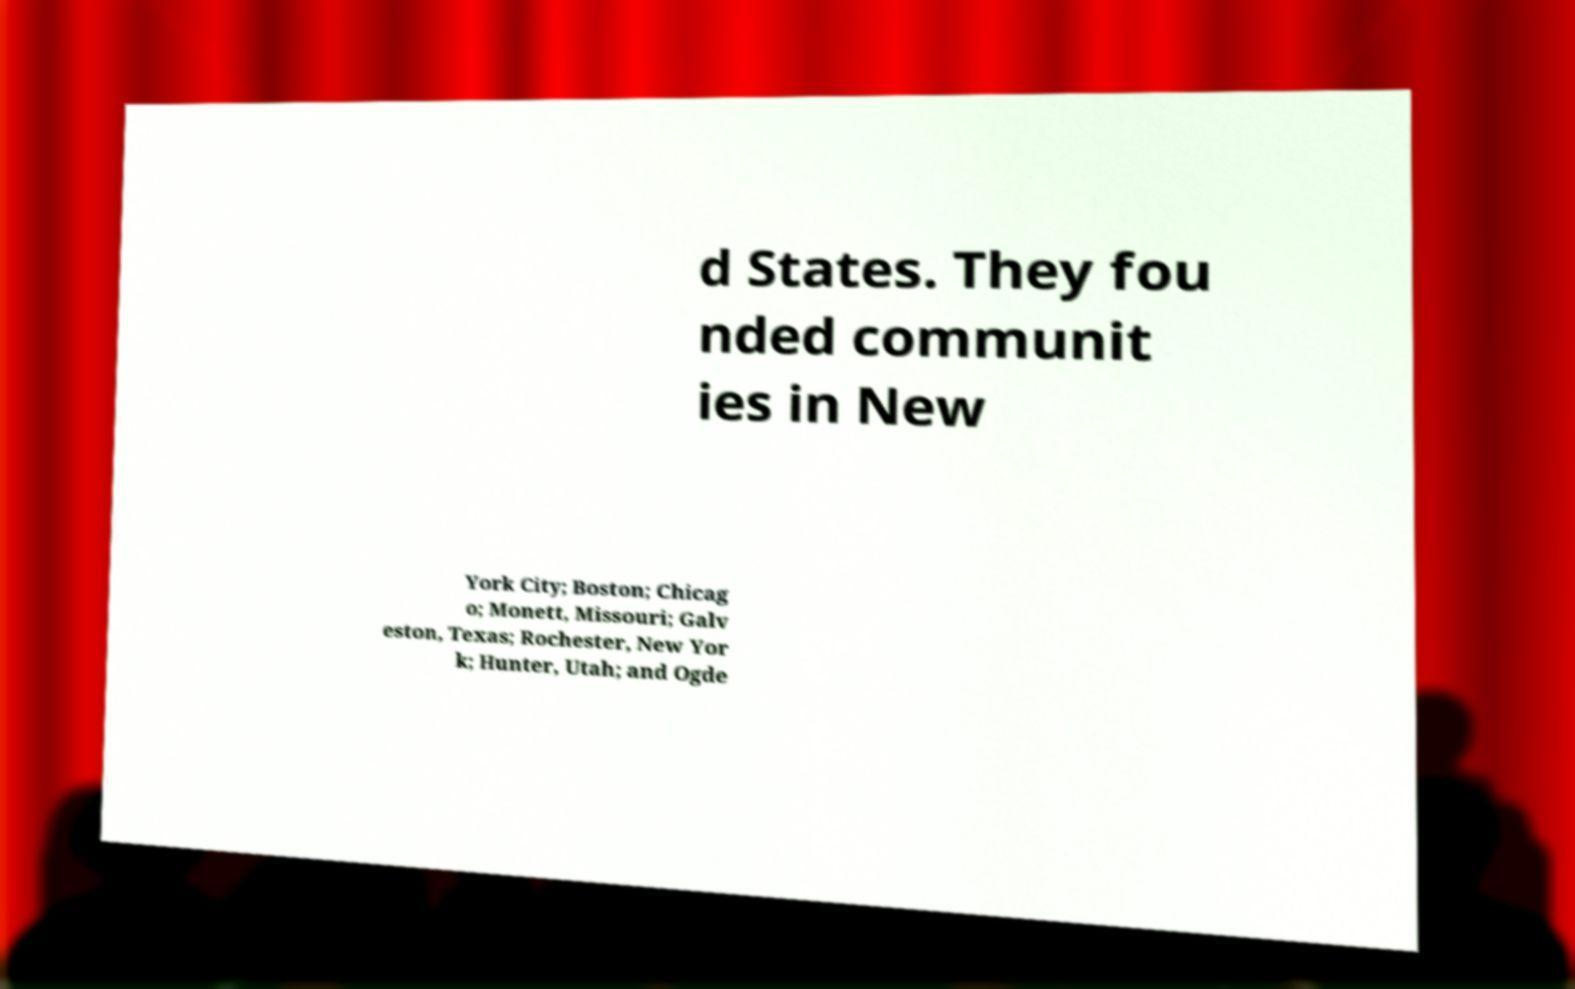Could you assist in decoding the text presented in this image and type it out clearly? d States. They fou nded communit ies in New York City; Boston; Chicag o; Monett, Missouri; Galv eston, Texas; Rochester, New Yor k; Hunter, Utah; and Ogde 